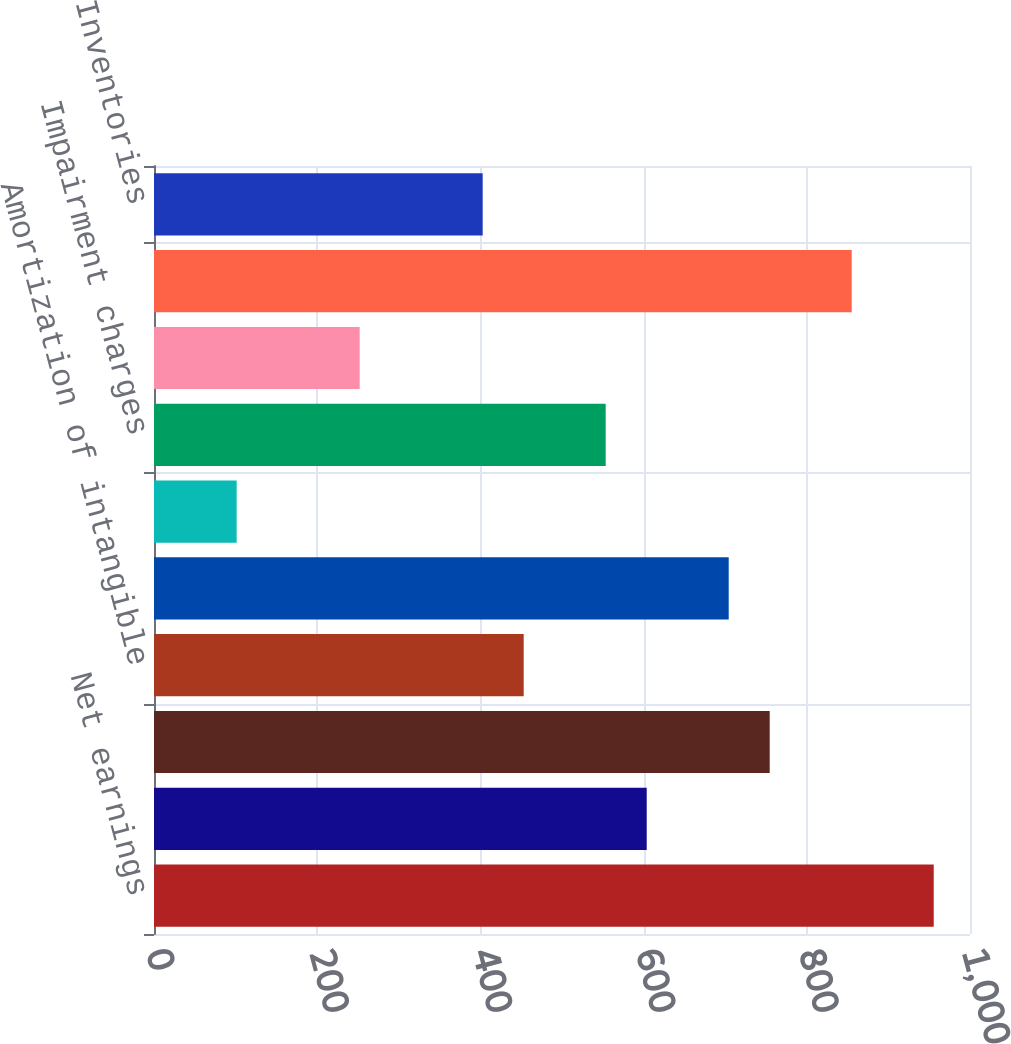Convert chart. <chart><loc_0><loc_0><loc_500><loc_500><bar_chart><fcel>Net earnings<fcel>Share-based compensation<fcel>Depreciation<fcel>Amortization of intangible<fcel>Deferred taxes<fcel>Provision to allowance for<fcel>Impairment charges<fcel>Other net<fcel>Trade and unbilled receivables<fcel>Inventories<nl><fcel>955.55<fcel>603.8<fcel>754.55<fcel>453.05<fcel>704.3<fcel>101.3<fcel>553.55<fcel>252.05<fcel>855.05<fcel>402.8<nl></chart> 